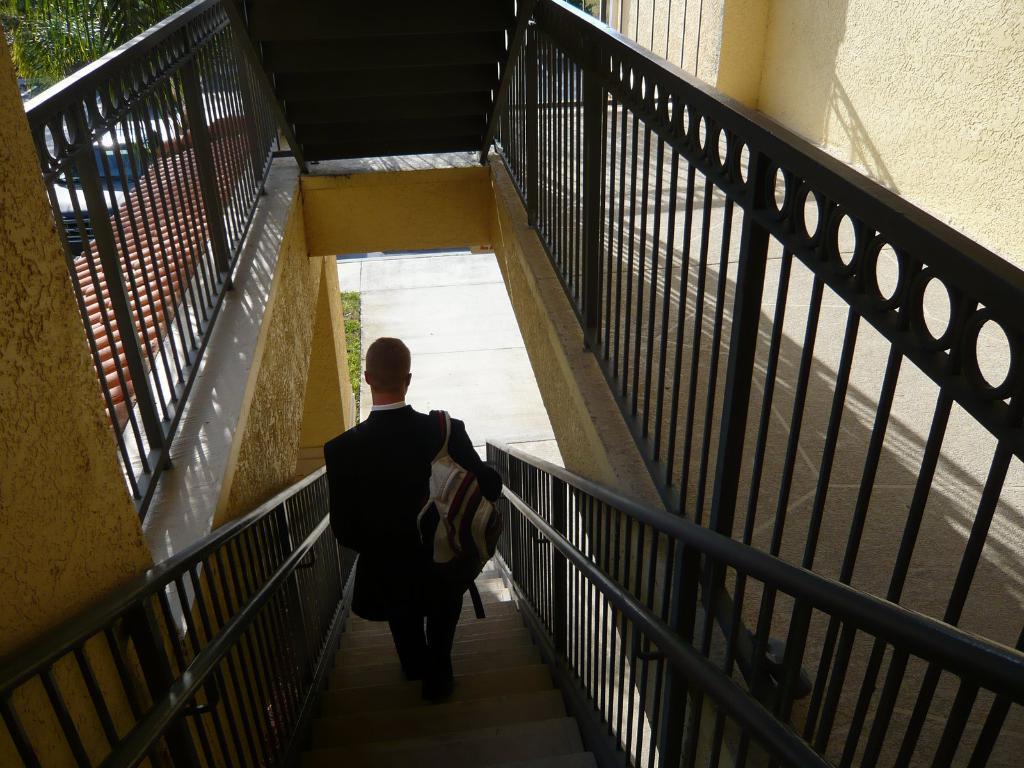In one or two sentences, can you explain what this image depicts? In this image I can see a person wearing black colored dress is standing on the stairs, the railing, the wall, the ground, the car on the ground and few trees which are green in color. 